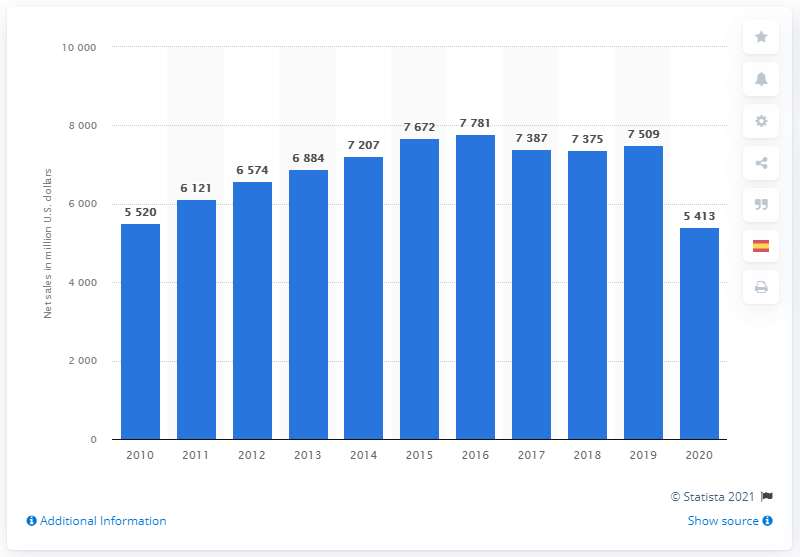Draw attention to some important aspects in this diagram. In 2020, Victoria's Secret's global net sales amounted to approximately $54,130,000 in dollars. In 2020, Victoria's Secret's global net sales amounted to approximately $5,413 million in dollars. 